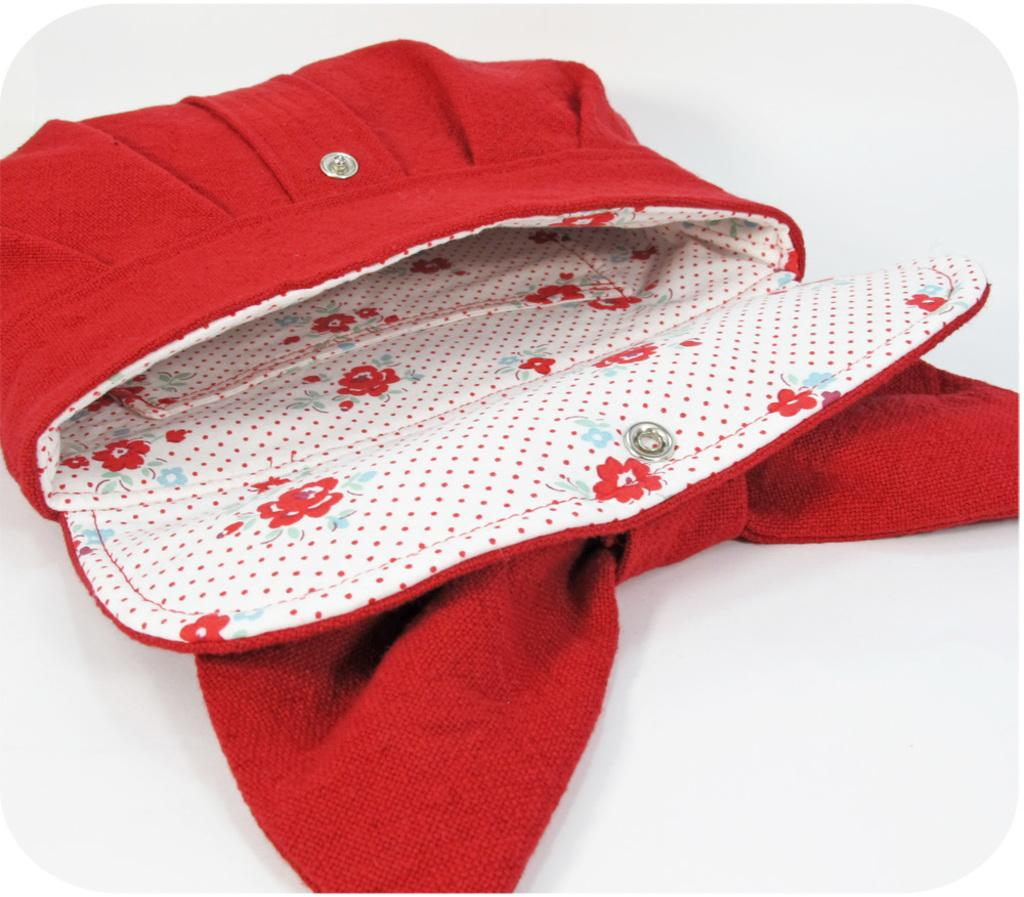What object is the main focus of the image? There is a woman's wallet in the image. Can you describe the color of the wallet? The wallet is red in color. How many kitties are sitting on the chairs in the image? There are no kitties or chairs present in the image; it only features a woman's red wallet. 